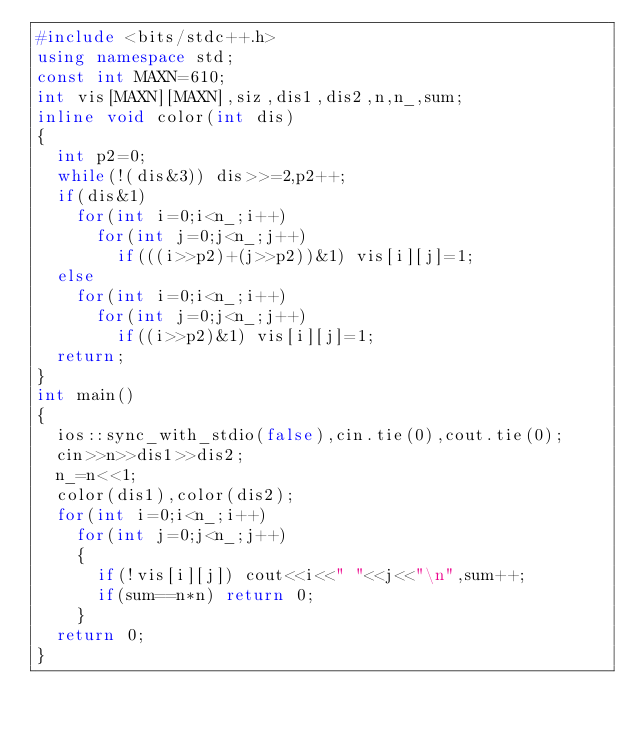Convert code to text. <code><loc_0><loc_0><loc_500><loc_500><_C++_>#include <bits/stdc++.h>
using namespace std;
const int MAXN=610;
int vis[MAXN][MAXN],siz,dis1,dis2,n,n_,sum;
inline void color(int dis)
{
	int p2=0;
	while(!(dis&3)) dis>>=2,p2++;
	if(dis&1)
		for(int i=0;i<n_;i++)
			for(int j=0;j<n_;j++)
				if(((i>>p2)+(j>>p2))&1) vis[i][j]=1;
	else
		for(int i=0;i<n_;i++)
			for(int j=0;j<n_;j++)
				if((i>>p2)&1) vis[i][j]=1;
	return;
}
int main()
{
	ios::sync_with_stdio(false),cin.tie(0),cout.tie(0);
	cin>>n>>dis1>>dis2;
	n_=n<<1;
	color(dis1),color(dis2);
	for(int i=0;i<n_;i++)
		for(int j=0;j<n_;j++)
		{
			if(!vis[i][j]) cout<<i<<" "<<j<<"\n",sum++;
			if(sum==n*n) return 0;
		}
	return 0;
}</code> 